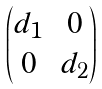<formula> <loc_0><loc_0><loc_500><loc_500>\begin{pmatrix} d _ { 1 } & 0 \\ 0 & d _ { 2 } \\ \end{pmatrix}</formula> 